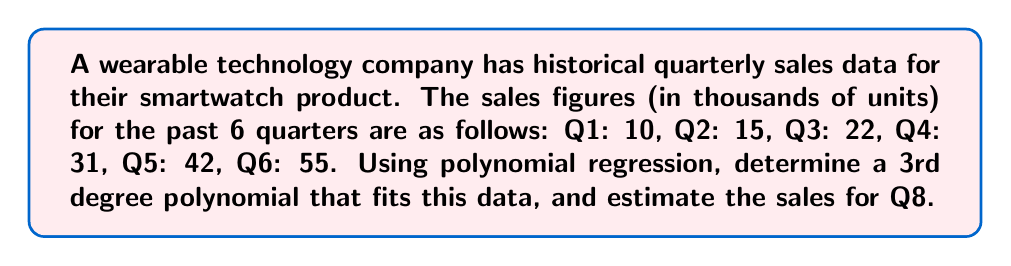Show me your answer to this math problem. 1. Let's use a 3rd degree polynomial of the form:
   $$y = ax^3 + bx^2 + cx + d$$
   where $y$ represents sales and $x$ represents the quarter number.

2. We need to solve for $a$, $b$, $c$, and $d$ using the given data points:
   $$(1, 10), (2, 15), (3, 22), (4, 31), (5, 42), (6, 55)$$

3. Using a polynomial regression calculator or software, we get the following equation:
   $$y = 0.1667x^3 - 0.5x^2 + 7.3333x + 3$$

4. To estimate sales for Q8, we substitute $x = 8$ into our equation:
   $$y = 0.1667(8^3) - 0.5(8^2) + 7.3333(8) + 3$$
   $$y = 0.1667(512) - 0.5(64) + 7.3333(8) + 3$$
   $$y = 85.3504 - 32 + 58.6664 + 3$$
   $$y = 115.0168$$

5. Rounding to the nearest thousand units (as per the original data):
   Estimated sales for Q8 ≈ 115 thousand units
Answer: 115 thousand units 